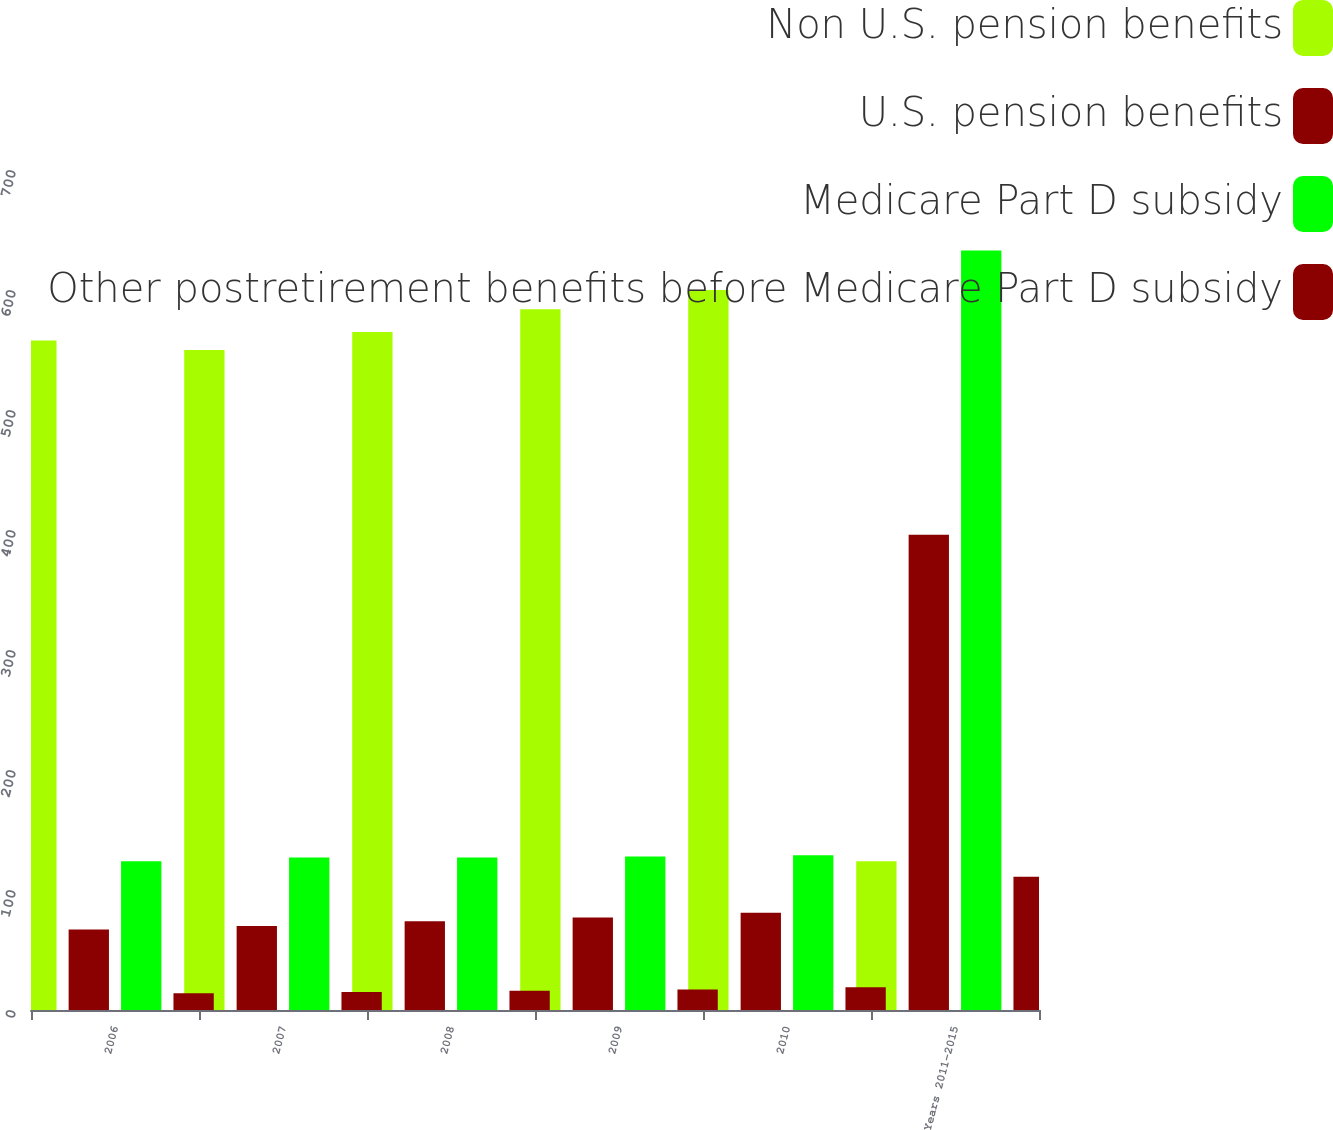Convert chart to OTSL. <chart><loc_0><loc_0><loc_500><loc_500><stacked_bar_chart><ecel><fcel>2006<fcel>2007<fcel>2008<fcel>2009<fcel>2010<fcel>Years 2011-2015<nl><fcel>Non U.S. pension benefits<fcel>558<fcel>550<fcel>565<fcel>584<fcel>600<fcel>124<nl><fcel>U.S. pension benefits<fcel>67<fcel>70<fcel>74<fcel>77<fcel>81<fcel>396<nl><fcel>Medicare Part D subsidy<fcel>124<fcel>127<fcel>127<fcel>128<fcel>129<fcel>633<nl><fcel>Other postretirement benefits before Medicare Part D subsidy<fcel>14<fcel>15<fcel>16<fcel>17<fcel>19<fcel>111<nl></chart> 